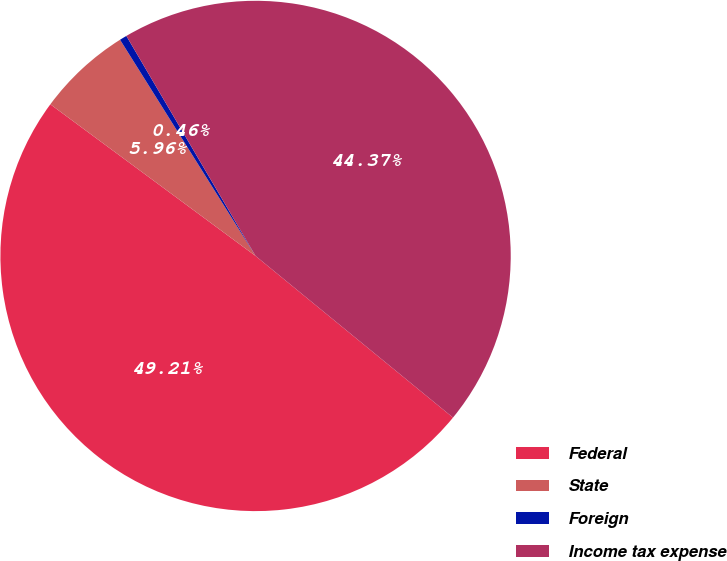<chart> <loc_0><loc_0><loc_500><loc_500><pie_chart><fcel>Federal<fcel>State<fcel>Foreign<fcel>Income tax expense<nl><fcel>49.21%<fcel>5.96%<fcel>0.46%<fcel>44.37%<nl></chart> 